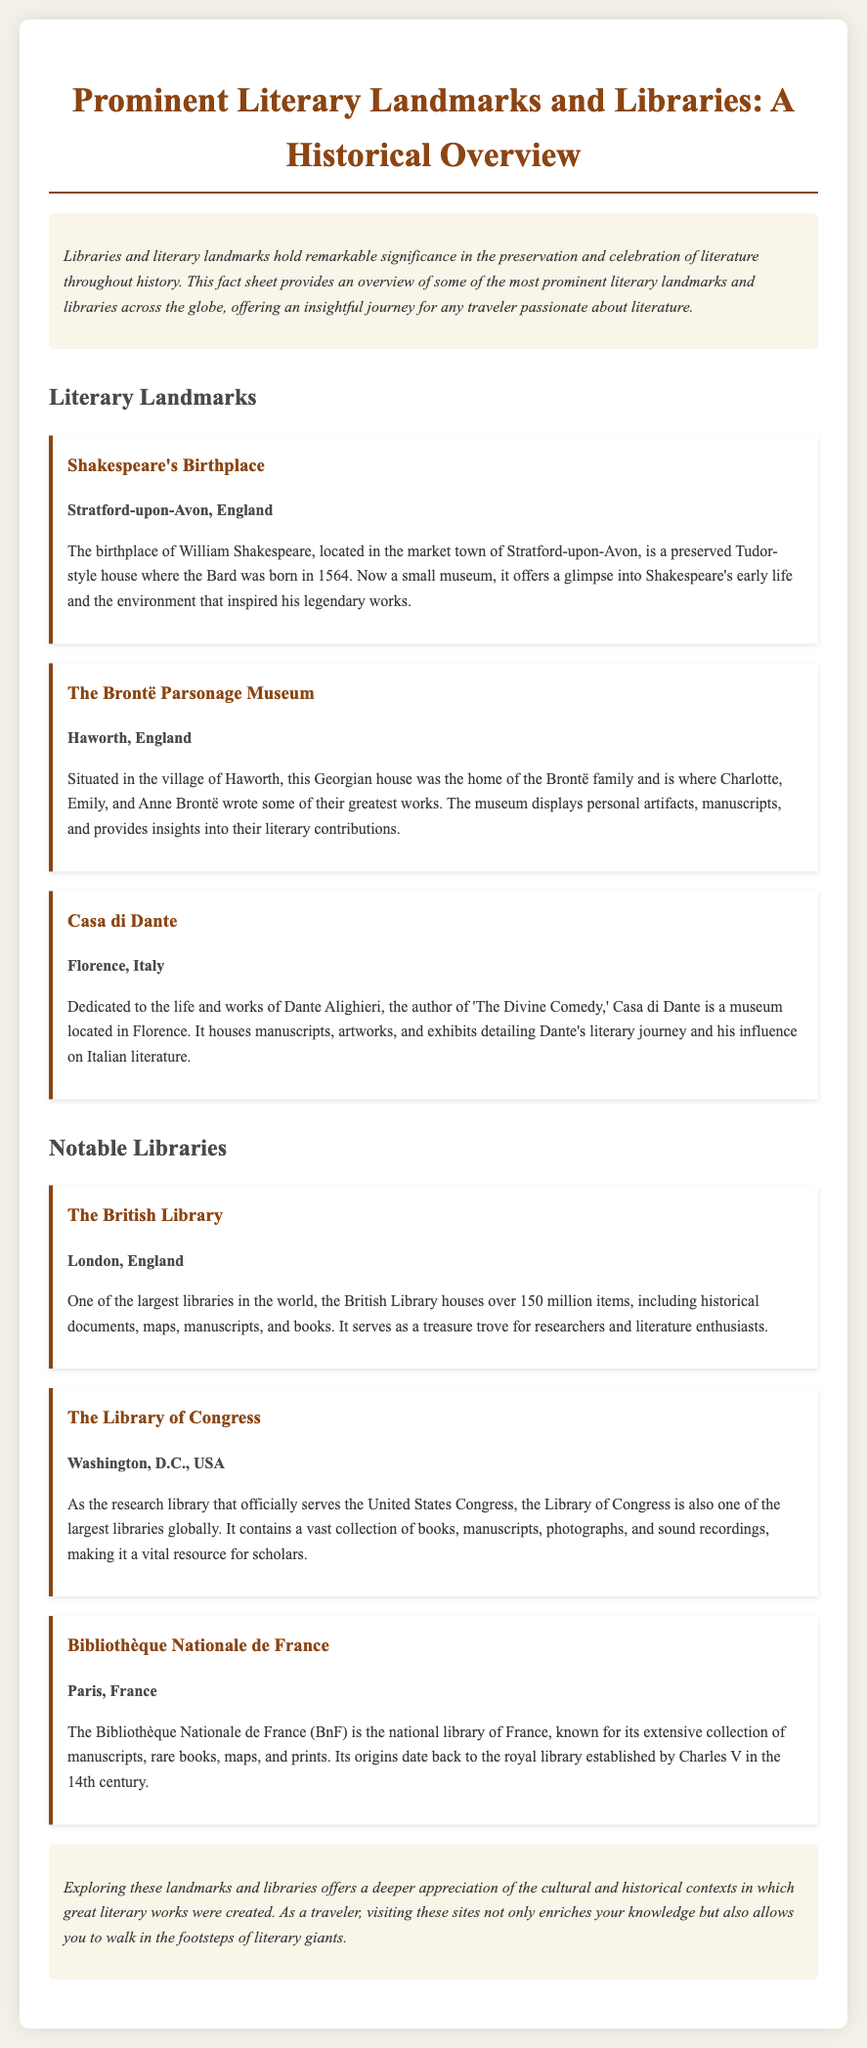What is the birthplace of William Shakespeare? The document states that Shakespeare's birthplace is a preserved house located in Stratford-upon-Avon, England.
Answer: Stratford-upon-Avon Which museum is dedicated to the Brontë family? The document specifies that the Brontë Parsonage Museum showcases the home of the Brontë siblings in Haworth, England.
Answer: The Brontë Parsonage Museum How many items does the British Library house? According to the document, the British Library contains over 150 million items, making it one of the largest libraries in the world.
Answer: Over 150 million What year was William Shakespeare born? The document mentions that Shakespeare was born in 1564.
Answer: 1564 In which city is the Bibliothèque Nationale de France located? The document states that the Bibliothèque Nationale de France is located in Paris.
Answer: Paris What type of documents does the Library of Congress contain? The document describes that the Library of Congress contains books, manuscripts, photographs, and sound recordings, indicating its broad collection type.
Answer: Books, manuscripts, photographs, and sound recordings What theme does the conclusion of the document emphasize? The conclusion highlights the appreciation of cultural and historical contexts related to literary works, encapsulating the overall theme of exploring literary landmarks.
Answer: Cultural and historical appreciation How does this fact sheet categorize its content? The document organizes its content into two main categories: Literary Landmarks and Notable Libraries.
Answer: Literary Landmarks and Notable Libraries 